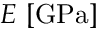<formula> <loc_0><loc_0><loc_500><loc_500>E \ [ G P a ]</formula> 